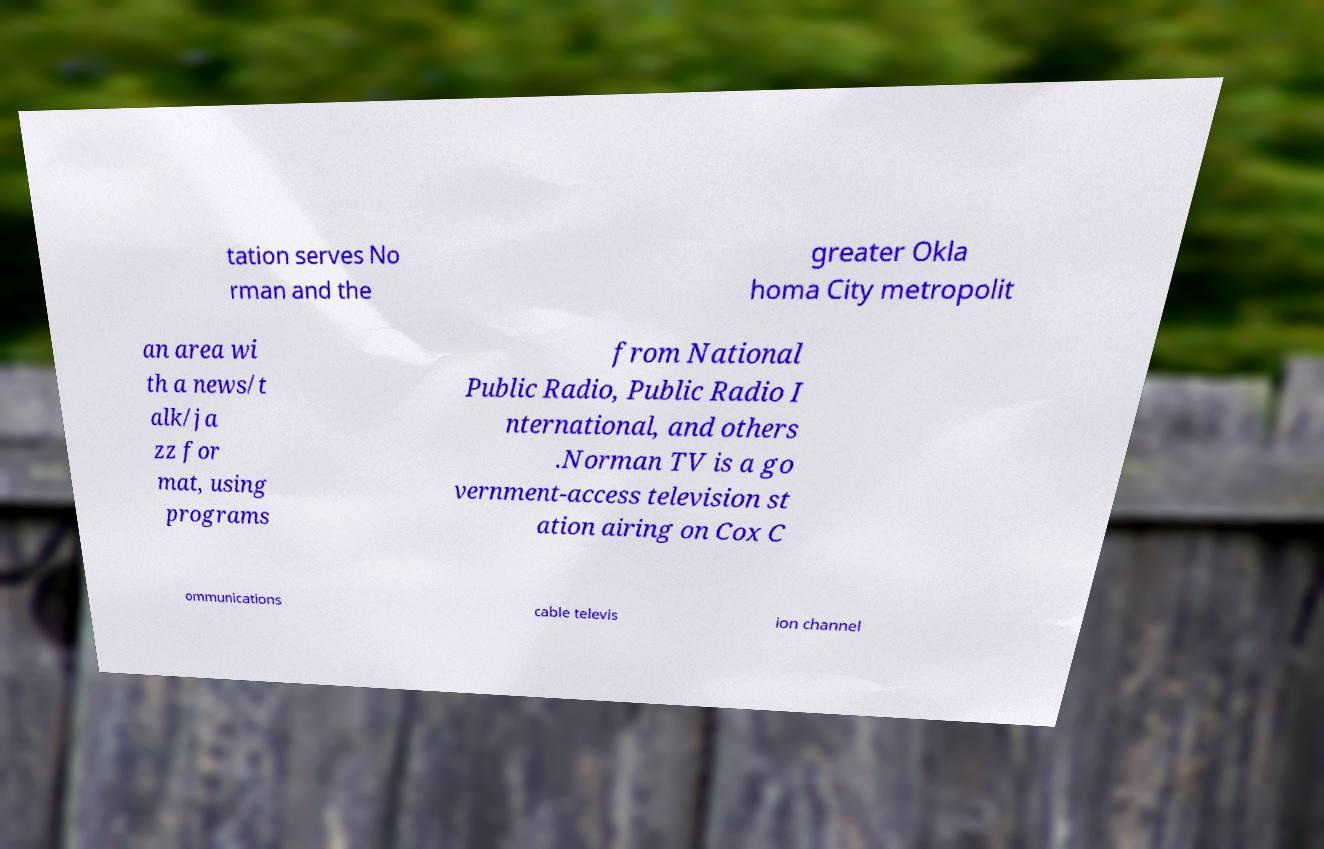Please identify and transcribe the text found in this image. tation serves No rman and the greater Okla homa City metropolit an area wi th a news/t alk/ja zz for mat, using programs from National Public Radio, Public Radio I nternational, and others .Norman TV is a go vernment-access television st ation airing on Cox C ommunications cable televis ion channel 